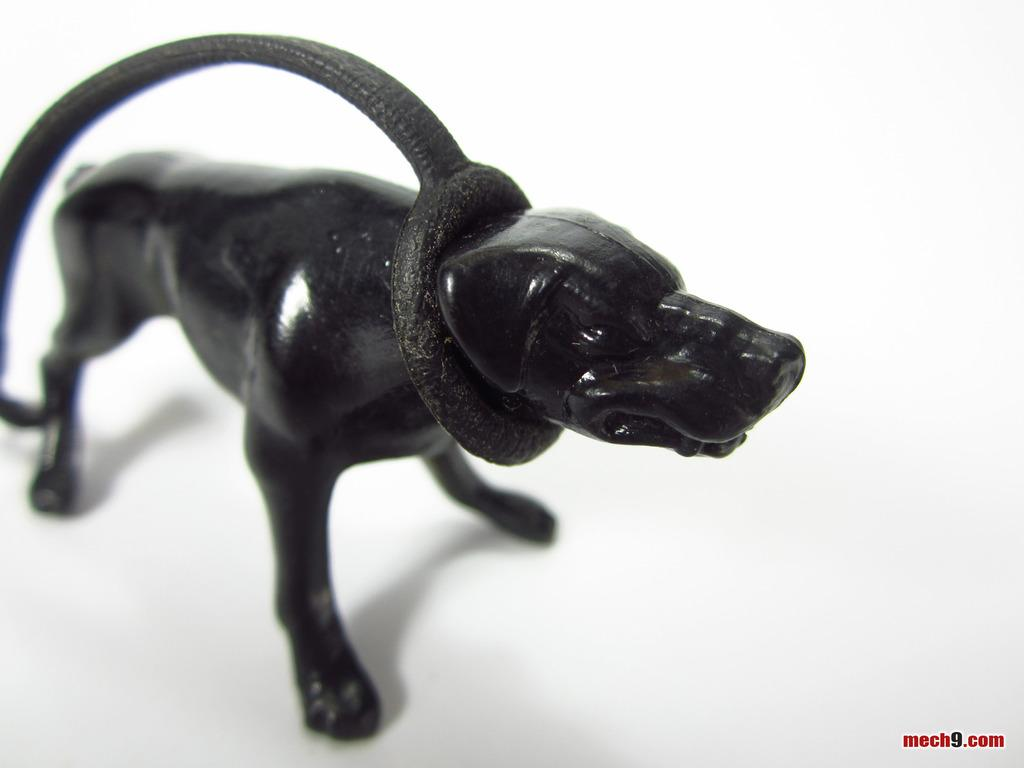What type of object is present in the image? There is a toy of an animal in the image. What is the name of the friend who helped the toy animal with its brain surgery? There is no friend or brain surgery mentioned in the image; it only features a toy of an animal. 